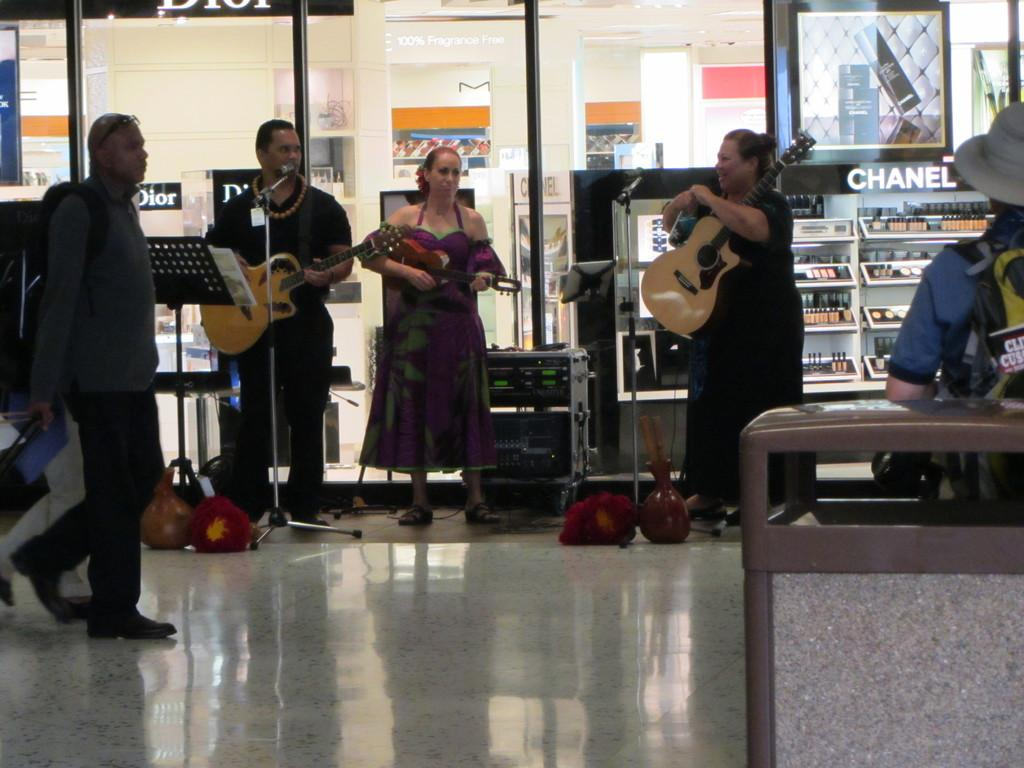What are the people in the image doing? There are 3 people performing by playing guitars. Can you describe the people on the sides of the image? A man is walking on the left side of the image, and a woman is standing on the right side of the image. What can be seen in the background of the image? There are glass doors in the background of the image, and it is a store. How many lockets are hanging from the guitar strings in the image? There are no lockets present in the image; it features people playing guitars. What is the total amount of money being exchanged between the people in the image? There is no indication of any monetary transactions in the image, as it focuses on the people playing guitars and the surrounding environment. 